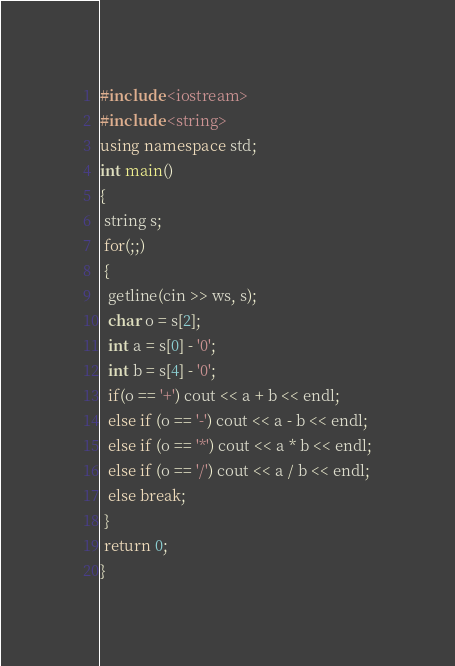<code> <loc_0><loc_0><loc_500><loc_500><_C++_>#include <iostream>
#include <string>
using namespace std;
int main()
{
 string s;
 for(;;)
 {
  getline(cin >> ws, s);
  char o = s[2];
  int a = s[0] - '0';
  int b = s[4] - '0';
  if(o == '+') cout << a + b << endl;
  else if (o == '-') cout << a - b << endl;
  else if (o == '*') cout << a * b << endl;
  else if (o == '/') cout << a / b << endl;
  else break;
 }
 return 0;
}</code> 